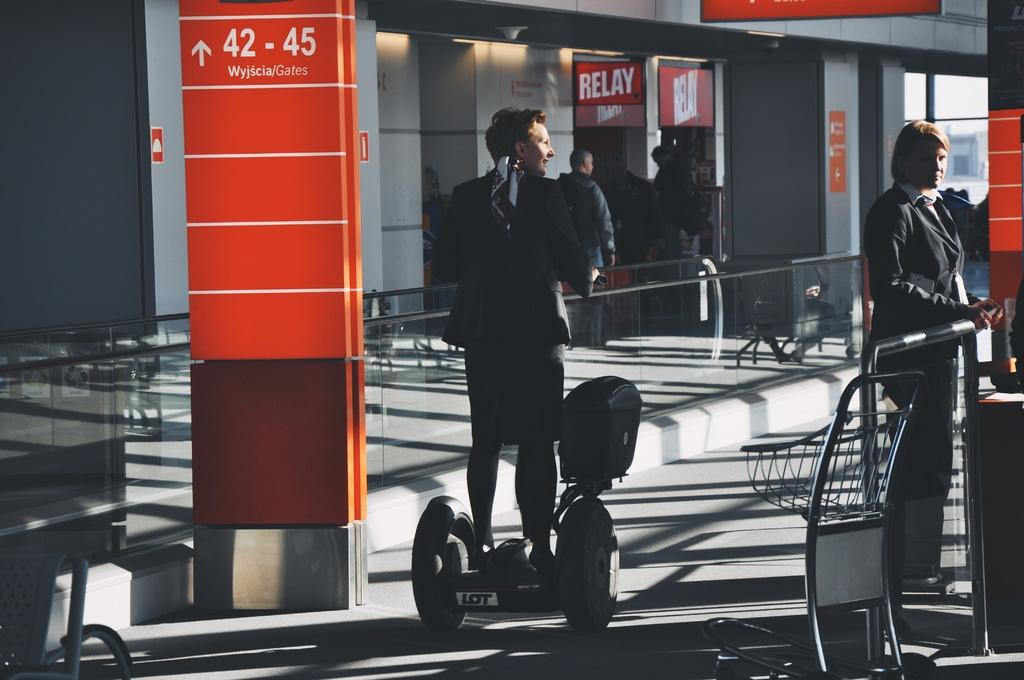How many people are in the image? There are people in the image, but the exact number is not specified. What is the man on the hoverboard doing? The man is standing on a hoverboard. What is on the floor near the man? There is a trolley on the floor. What can be seen near the railings in the image? Posters are present in the image. What other objects can be seen in the image? There are other objects in the image, but their specific details are not provided. What is visible in the background of the image? There is a building in the background of the image. What type of division is taking place in the image? There is no division taking place in the image. Can you tell me when the birth of the person on the hoverboard occurred? There is no information about the birth of the person on the hoverboard in the image. 